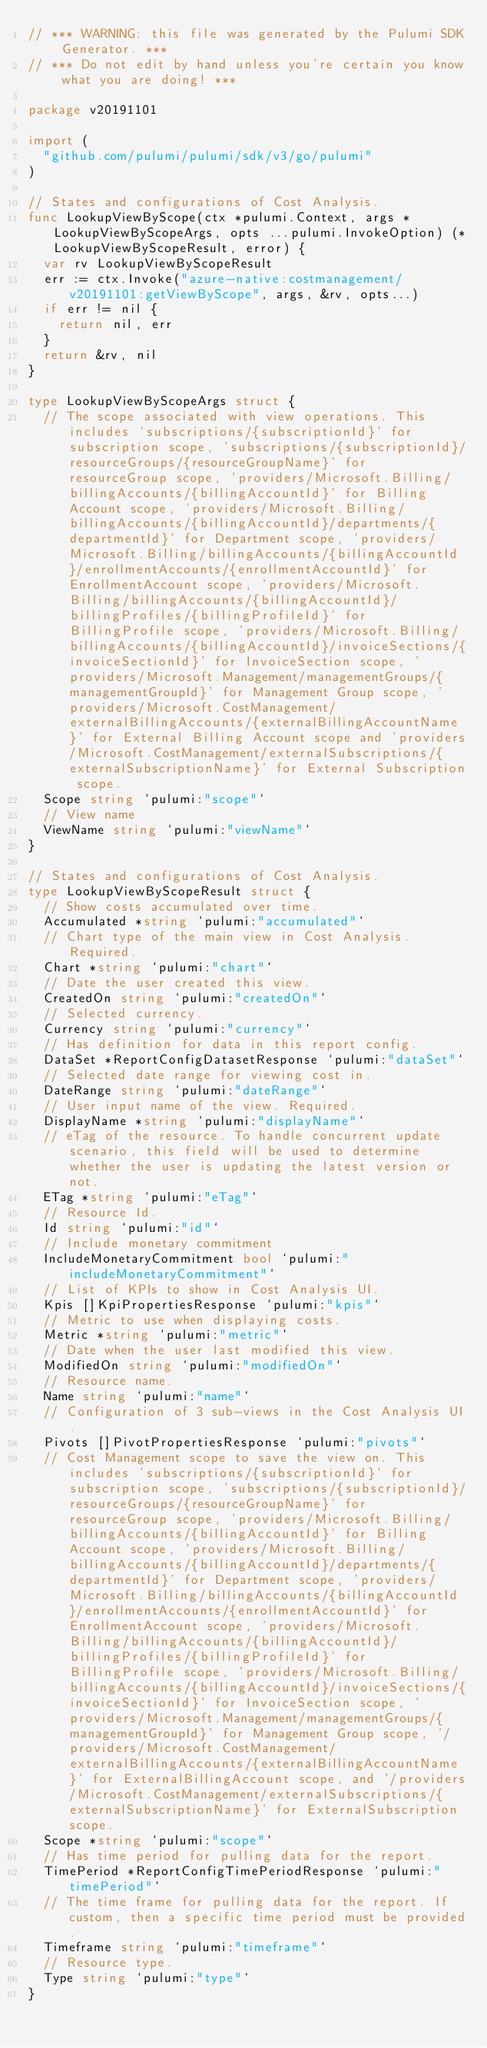<code> <loc_0><loc_0><loc_500><loc_500><_Go_>// *** WARNING: this file was generated by the Pulumi SDK Generator. ***
// *** Do not edit by hand unless you're certain you know what you are doing! ***

package v20191101

import (
	"github.com/pulumi/pulumi/sdk/v3/go/pulumi"
)

// States and configurations of Cost Analysis.
func LookupViewByScope(ctx *pulumi.Context, args *LookupViewByScopeArgs, opts ...pulumi.InvokeOption) (*LookupViewByScopeResult, error) {
	var rv LookupViewByScopeResult
	err := ctx.Invoke("azure-native:costmanagement/v20191101:getViewByScope", args, &rv, opts...)
	if err != nil {
		return nil, err
	}
	return &rv, nil
}

type LookupViewByScopeArgs struct {
	// The scope associated with view operations. This includes 'subscriptions/{subscriptionId}' for subscription scope, 'subscriptions/{subscriptionId}/resourceGroups/{resourceGroupName}' for resourceGroup scope, 'providers/Microsoft.Billing/billingAccounts/{billingAccountId}' for Billing Account scope, 'providers/Microsoft.Billing/billingAccounts/{billingAccountId}/departments/{departmentId}' for Department scope, 'providers/Microsoft.Billing/billingAccounts/{billingAccountId}/enrollmentAccounts/{enrollmentAccountId}' for EnrollmentAccount scope, 'providers/Microsoft.Billing/billingAccounts/{billingAccountId}/billingProfiles/{billingProfileId}' for BillingProfile scope, 'providers/Microsoft.Billing/billingAccounts/{billingAccountId}/invoiceSections/{invoiceSectionId}' for InvoiceSection scope, 'providers/Microsoft.Management/managementGroups/{managementGroupId}' for Management Group scope, 'providers/Microsoft.CostManagement/externalBillingAccounts/{externalBillingAccountName}' for External Billing Account scope and 'providers/Microsoft.CostManagement/externalSubscriptions/{externalSubscriptionName}' for External Subscription scope.
	Scope string `pulumi:"scope"`
	// View name
	ViewName string `pulumi:"viewName"`
}

// States and configurations of Cost Analysis.
type LookupViewByScopeResult struct {
	// Show costs accumulated over time.
	Accumulated *string `pulumi:"accumulated"`
	// Chart type of the main view in Cost Analysis. Required.
	Chart *string `pulumi:"chart"`
	// Date the user created this view.
	CreatedOn string `pulumi:"createdOn"`
	// Selected currency.
	Currency string `pulumi:"currency"`
	// Has definition for data in this report config.
	DataSet *ReportConfigDatasetResponse `pulumi:"dataSet"`
	// Selected date range for viewing cost in.
	DateRange string `pulumi:"dateRange"`
	// User input name of the view. Required.
	DisplayName *string `pulumi:"displayName"`
	// eTag of the resource. To handle concurrent update scenario, this field will be used to determine whether the user is updating the latest version or not.
	ETag *string `pulumi:"eTag"`
	// Resource Id.
	Id string `pulumi:"id"`
	// Include monetary commitment
	IncludeMonetaryCommitment bool `pulumi:"includeMonetaryCommitment"`
	// List of KPIs to show in Cost Analysis UI.
	Kpis []KpiPropertiesResponse `pulumi:"kpis"`
	// Metric to use when displaying costs.
	Metric *string `pulumi:"metric"`
	// Date when the user last modified this view.
	ModifiedOn string `pulumi:"modifiedOn"`
	// Resource name.
	Name string `pulumi:"name"`
	// Configuration of 3 sub-views in the Cost Analysis UI.
	Pivots []PivotPropertiesResponse `pulumi:"pivots"`
	// Cost Management scope to save the view on. This includes 'subscriptions/{subscriptionId}' for subscription scope, 'subscriptions/{subscriptionId}/resourceGroups/{resourceGroupName}' for resourceGroup scope, 'providers/Microsoft.Billing/billingAccounts/{billingAccountId}' for Billing Account scope, 'providers/Microsoft.Billing/billingAccounts/{billingAccountId}/departments/{departmentId}' for Department scope, 'providers/Microsoft.Billing/billingAccounts/{billingAccountId}/enrollmentAccounts/{enrollmentAccountId}' for EnrollmentAccount scope, 'providers/Microsoft.Billing/billingAccounts/{billingAccountId}/billingProfiles/{billingProfileId}' for BillingProfile scope, 'providers/Microsoft.Billing/billingAccounts/{billingAccountId}/invoiceSections/{invoiceSectionId}' for InvoiceSection scope, 'providers/Microsoft.Management/managementGroups/{managementGroupId}' for Management Group scope, '/providers/Microsoft.CostManagement/externalBillingAccounts/{externalBillingAccountName}' for ExternalBillingAccount scope, and '/providers/Microsoft.CostManagement/externalSubscriptions/{externalSubscriptionName}' for ExternalSubscription scope.
	Scope *string `pulumi:"scope"`
	// Has time period for pulling data for the report.
	TimePeriod *ReportConfigTimePeriodResponse `pulumi:"timePeriod"`
	// The time frame for pulling data for the report. If custom, then a specific time period must be provided.
	Timeframe string `pulumi:"timeframe"`
	// Resource type.
	Type string `pulumi:"type"`
}
</code> 